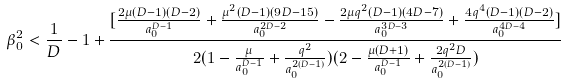<formula> <loc_0><loc_0><loc_500><loc_500>\beta _ { 0 } ^ { 2 } < \frac { 1 } { D } - 1 + \frac { [ \frac { 2 \mu ( D - 1 ) ( D - 2 ) } { a _ { 0 } ^ { D - 1 } } + \frac { \mu ^ { 2 } ( D - 1 ) ( 9 D - 1 5 ) } { a _ { 0 } ^ { 2 D - 2 } } - \frac { 2 \mu q ^ { 2 } ( D - 1 ) ( 4 D - 7 ) } { a _ { 0 } ^ { 3 D - 3 } } + \frac { 4 q ^ { 4 } ( D - 1 ) ( D - 2 ) } { a _ { 0 } ^ { 4 D - 4 } } ] } { 2 ( 1 - \frac { \mu } { a _ { 0 } ^ { D - 1 } } + \frac { q ^ { 2 } } { a _ { 0 } ^ { 2 ( D - 1 ) } } ) ( 2 - \frac { \mu ( D + 1 ) } { a _ { 0 } ^ { D - 1 } } + \frac { 2 q ^ { 2 } D } { a _ { 0 } ^ { 2 ( D - 1 ) } } ) }</formula> 